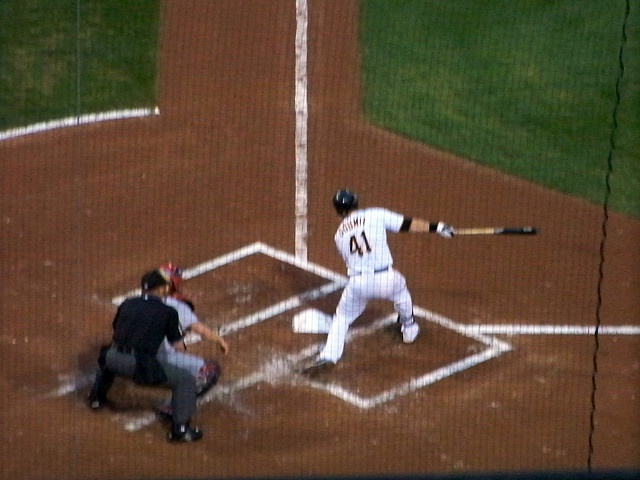Describe the objects in this image and their specific colors. I can see people in darkgreen, black, gray, and maroon tones, people in darkgreen, lavender, darkgray, and black tones, people in darkgreen, black, maroon, gray, and darkgray tones, and baseball bat in darkgreen, black, tan, gray, and maroon tones in this image. 